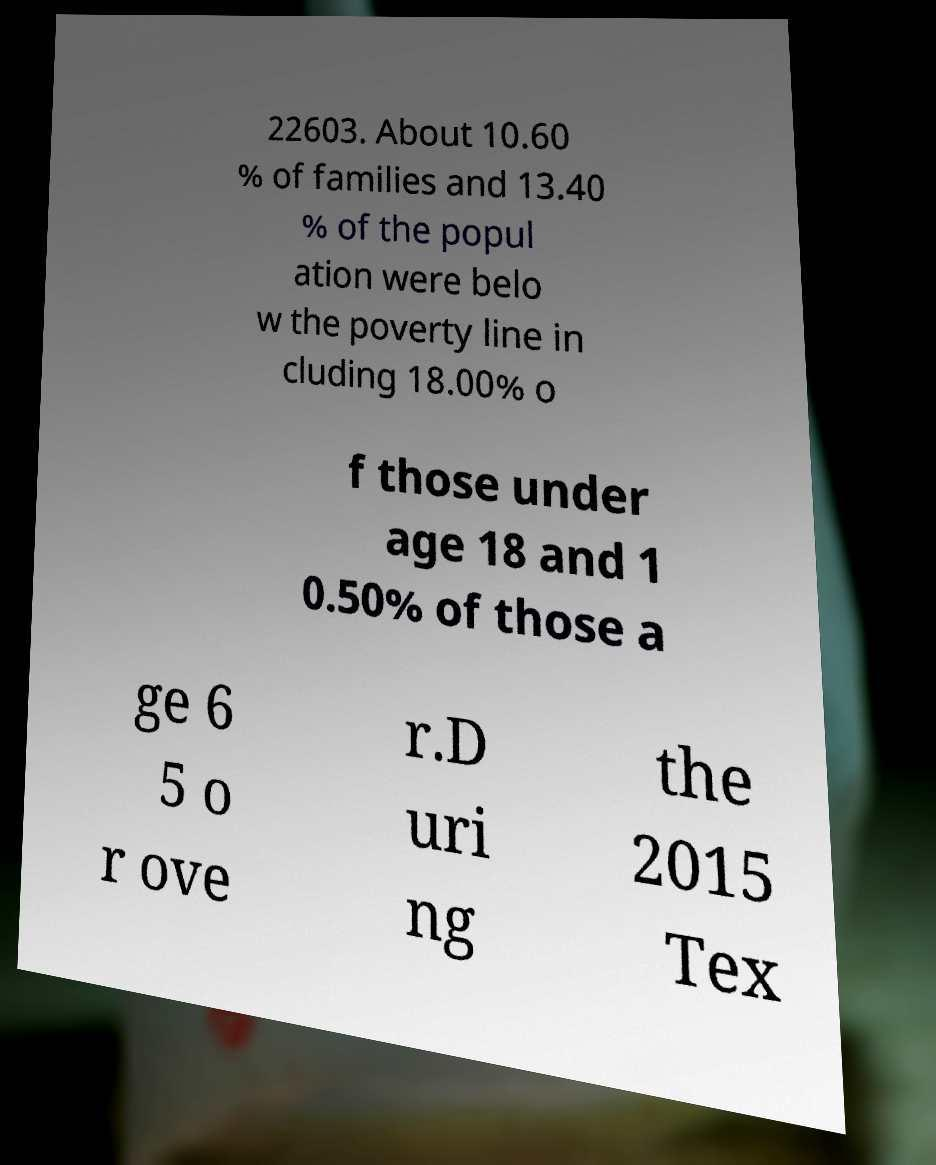Could you assist in decoding the text presented in this image and type it out clearly? 22603. About 10.60 % of families and 13.40 % of the popul ation were belo w the poverty line in cluding 18.00% o f those under age 18 and 1 0.50% of those a ge 6 5 o r ove r.D uri ng the 2015 Tex 